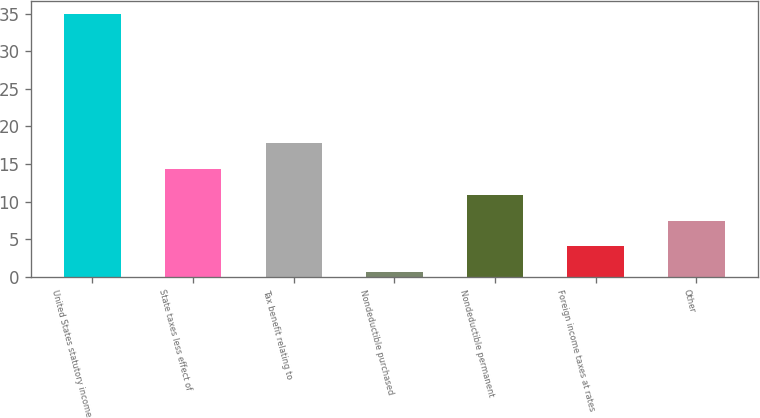Convert chart. <chart><loc_0><loc_0><loc_500><loc_500><bar_chart><fcel>United States statutory income<fcel>State taxes less effect of<fcel>Tax benefit relating to<fcel>Nondeductible purchased<fcel>Nondeductible permanent<fcel>Foreign income taxes at rates<fcel>Other<nl><fcel>35<fcel>14.36<fcel>17.8<fcel>0.6<fcel>10.92<fcel>4.04<fcel>7.48<nl></chart> 